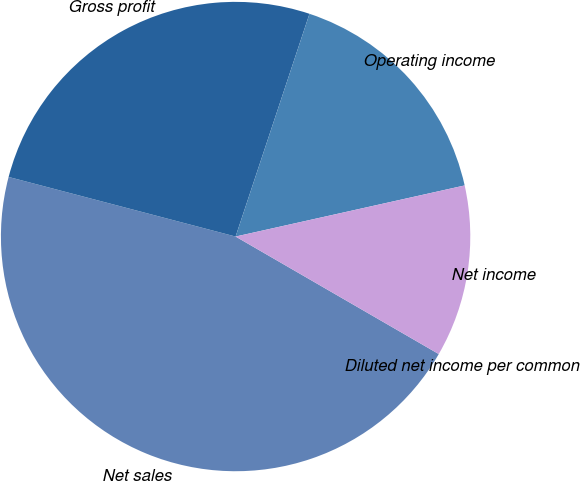Convert chart. <chart><loc_0><loc_0><loc_500><loc_500><pie_chart><fcel>Net sales<fcel>Gross profit<fcel>Operating income<fcel>Net income<fcel>Diluted net income per common<nl><fcel>45.74%<fcel>26.01%<fcel>16.41%<fcel>11.84%<fcel>0.0%<nl></chart> 